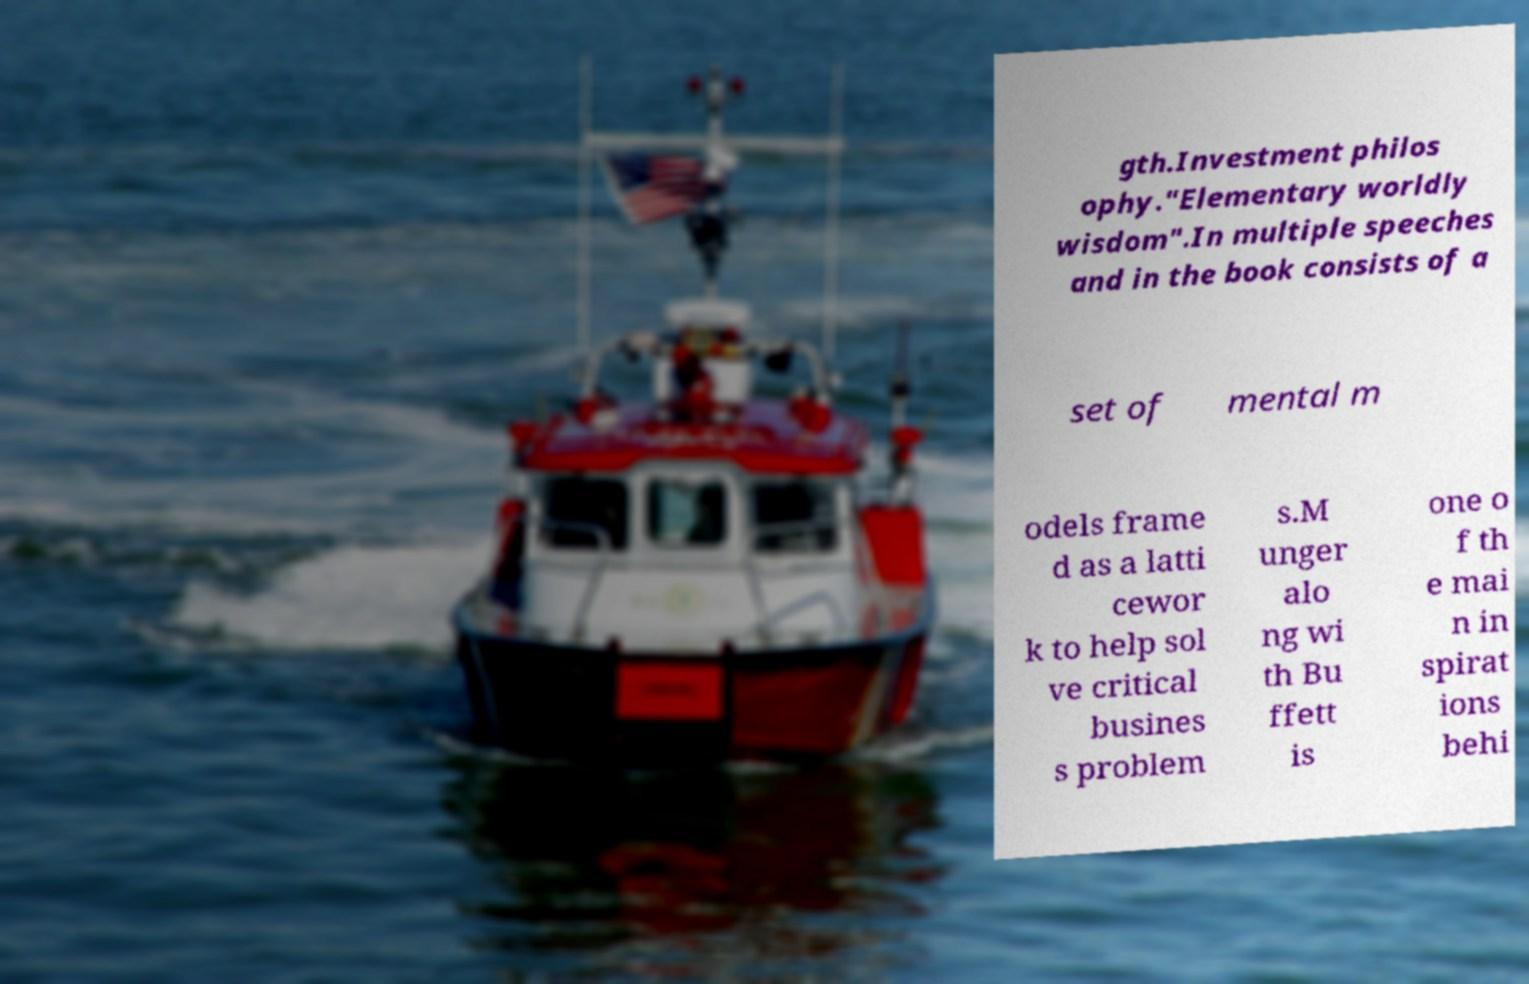Could you extract and type out the text from this image? gth.Investment philos ophy."Elementary worldly wisdom".In multiple speeches and in the book consists of a set of mental m odels frame d as a latti cewor k to help sol ve critical busines s problem s.M unger alo ng wi th Bu ffett is one o f th e mai n in spirat ions behi 